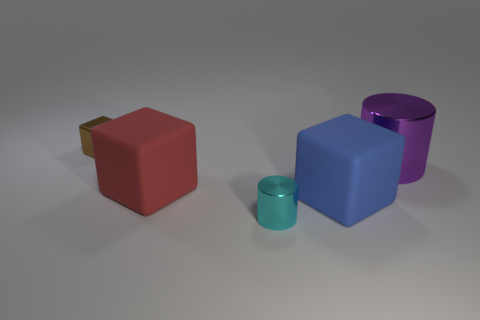Add 1 small gray metal balls. How many objects exist? 6 Subtract all shiny cubes. How many cubes are left? 2 Subtract all cylinders. How many objects are left? 3 Add 3 blue rubber cubes. How many blue rubber cubes are left? 4 Add 1 purple cylinders. How many purple cylinders exist? 2 Subtract 0 red spheres. How many objects are left? 5 Subtract all purple blocks. Subtract all blue cylinders. How many blocks are left? 3 Subtract all big red matte objects. Subtract all big gray metallic objects. How many objects are left? 4 